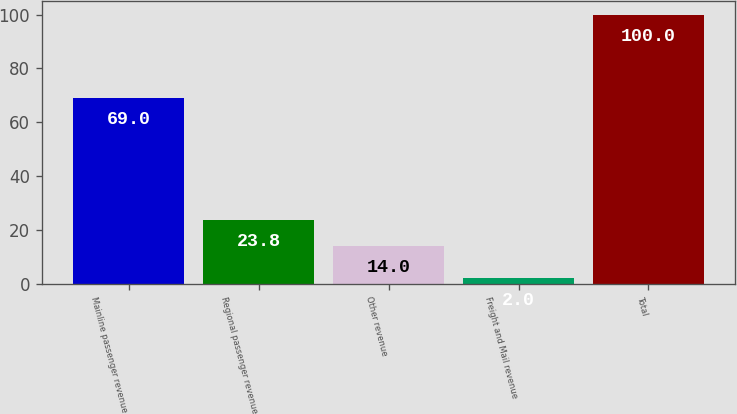Convert chart. <chart><loc_0><loc_0><loc_500><loc_500><bar_chart><fcel>Mainline passenger revenue<fcel>Regional passenger revenue<fcel>Other revenue<fcel>Freight and Mail revenue<fcel>Total<nl><fcel>69<fcel>23.8<fcel>14<fcel>2<fcel>100<nl></chart> 